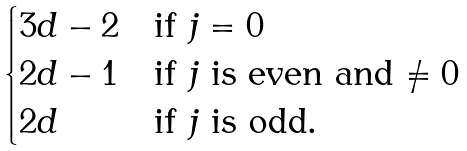<formula> <loc_0><loc_0><loc_500><loc_500>\begin{cases} 3 d - 2 & \text {if $j=0$} \\ 2 d - 1 & \text {if $j$ is even and $\neq0$} \\ 2 d & \text {if $j$ is odd.} \end{cases}</formula> 